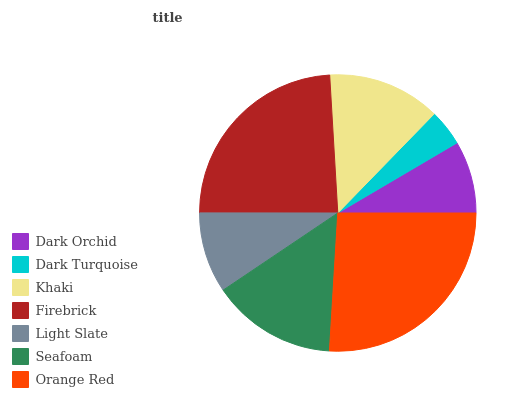Is Dark Turquoise the minimum?
Answer yes or no. Yes. Is Orange Red the maximum?
Answer yes or no. Yes. Is Khaki the minimum?
Answer yes or no. No. Is Khaki the maximum?
Answer yes or no. No. Is Khaki greater than Dark Turquoise?
Answer yes or no. Yes. Is Dark Turquoise less than Khaki?
Answer yes or no. Yes. Is Dark Turquoise greater than Khaki?
Answer yes or no. No. Is Khaki less than Dark Turquoise?
Answer yes or no. No. Is Khaki the high median?
Answer yes or no. Yes. Is Khaki the low median?
Answer yes or no. Yes. Is Orange Red the high median?
Answer yes or no. No. Is Seafoam the low median?
Answer yes or no. No. 